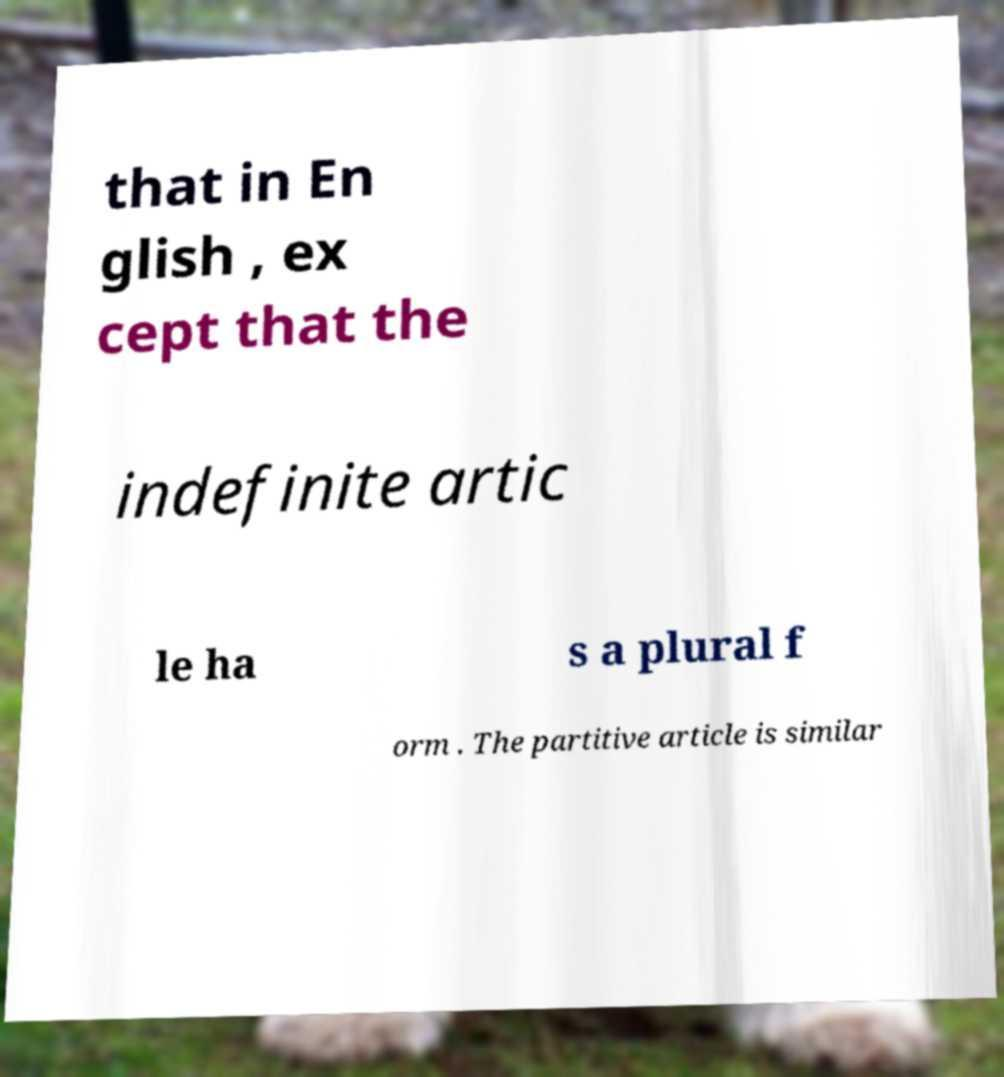Can you accurately transcribe the text from the provided image for me? that in En glish , ex cept that the indefinite artic le ha s a plural f orm . The partitive article is similar 